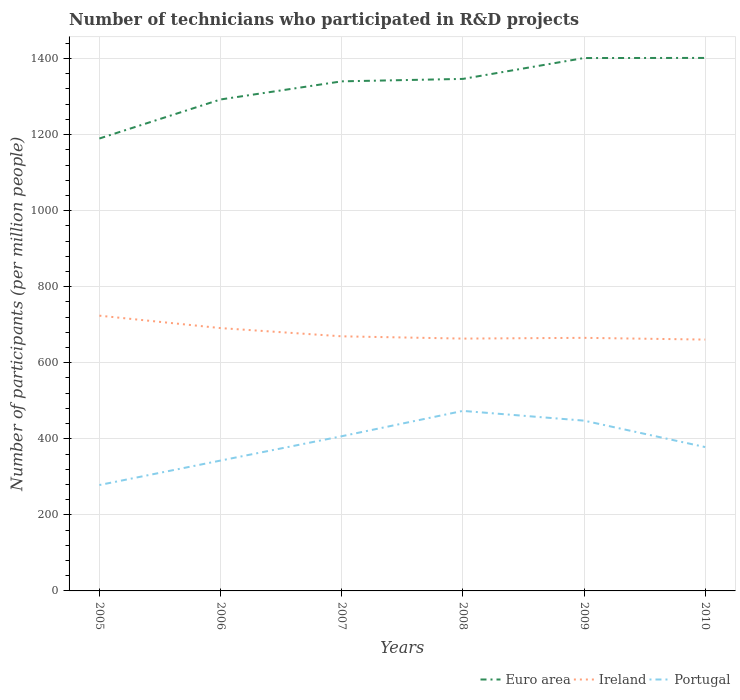How many different coloured lines are there?
Offer a very short reply. 3. Does the line corresponding to Euro area intersect with the line corresponding to Ireland?
Give a very brief answer. No. Is the number of lines equal to the number of legend labels?
Make the answer very short. Yes. Across all years, what is the maximum number of technicians who participated in R&D projects in Ireland?
Give a very brief answer. 660.99. In which year was the number of technicians who participated in R&D projects in Portugal maximum?
Your answer should be compact. 2005. What is the total number of technicians who participated in R&D projects in Ireland in the graph?
Keep it short and to the point. 4.57. What is the difference between the highest and the second highest number of technicians who participated in R&D projects in Ireland?
Provide a short and direct response. 62.9. Is the number of technicians who participated in R&D projects in Ireland strictly greater than the number of technicians who participated in R&D projects in Portugal over the years?
Offer a very short reply. No. What is the difference between two consecutive major ticks on the Y-axis?
Your answer should be very brief. 200. What is the title of the graph?
Provide a short and direct response. Number of technicians who participated in R&D projects. What is the label or title of the Y-axis?
Your response must be concise. Number of participants (per million people). What is the Number of participants (per million people) in Euro area in 2005?
Ensure brevity in your answer.  1189.74. What is the Number of participants (per million people) of Ireland in 2005?
Your answer should be compact. 723.89. What is the Number of participants (per million people) of Portugal in 2005?
Provide a short and direct response. 278.47. What is the Number of participants (per million people) in Euro area in 2006?
Offer a very short reply. 1292.42. What is the Number of participants (per million people) of Ireland in 2006?
Your answer should be compact. 691.21. What is the Number of participants (per million people) of Portugal in 2006?
Your answer should be very brief. 342.81. What is the Number of participants (per million people) of Euro area in 2007?
Offer a terse response. 1340.09. What is the Number of participants (per million people) in Ireland in 2007?
Give a very brief answer. 669.57. What is the Number of participants (per million people) in Portugal in 2007?
Keep it short and to the point. 406.8. What is the Number of participants (per million people) of Euro area in 2008?
Offer a very short reply. 1346.52. What is the Number of participants (per million people) in Ireland in 2008?
Your response must be concise. 663.59. What is the Number of participants (per million people) in Portugal in 2008?
Your response must be concise. 473.42. What is the Number of participants (per million people) in Euro area in 2009?
Provide a succinct answer. 1401.39. What is the Number of participants (per million people) in Ireland in 2009?
Offer a terse response. 665.55. What is the Number of participants (per million people) of Portugal in 2009?
Your answer should be compact. 447.8. What is the Number of participants (per million people) of Euro area in 2010?
Your response must be concise. 1401.67. What is the Number of participants (per million people) of Ireland in 2010?
Ensure brevity in your answer.  660.99. What is the Number of participants (per million people) of Portugal in 2010?
Offer a very short reply. 378.29. Across all years, what is the maximum Number of participants (per million people) in Euro area?
Offer a very short reply. 1401.67. Across all years, what is the maximum Number of participants (per million people) in Ireland?
Your response must be concise. 723.89. Across all years, what is the maximum Number of participants (per million people) in Portugal?
Your answer should be compact. 473.42. Across all years, what is the minimum Number of participants (per million people) of Euro area?
Offer a very short reply. 1189.74. Across all years, what is the minimum Number of participants (per million people) in Ireland?
Ensure brevity in your answer.  660.99. Across all years, what is the minimum Number of participants (per million people) of Portugal?
Offer a very short reply. 278.47. What is the total Number of participants (per million people) of Euro area in the graph?
Offer a very short reply. 7971.83. What is the total Number of participants (per million people) of Ireland in the graph?
Your answer should be very brief. 4074.8. What is the total Number of participants (per million people) in Portugal in the graph?
Your answer should be very brief. 2327.59. What is the difference between the Number of participants (per million people) of Euro area in 2005 and that in 2006?
Your response must be concise. -102.68. What is the difference between the Number of participants (per million people) in Ireland in 2005 and that in 2006?
Provide a succinct answer. 32.68. What is the difference between the Number of participants (per million people) of Portugal in 2005 and that in 2006?
Your answer should be compact. -64.34. What is the difference between the Number of participants (per million people) of Euro area in 2005 and that in 2007?
Give a very brief answer. -150.35. What is the difference between the Number of participants (per million people) of Ireland in 2005 and that in 2007?
Make the answer very short. 54.31. What is the difference between the Number of participants (per million people) in Portugal in 2005 and that in 2007?
Make the answer very short. -128.33. What is the difference between the Number of participants (per million people) in Euro area in 2005 and that in 2008?
Provide a succinct answer. -156.78. What is the difference between the Number of participants (per million people) of Ireland in 2005 and that in 2008?
Your answer should be very brief. 60.29. What is the difference between the Number of participants (per million people) in Portugal in 2005 and that in 2008?
Provide a succinct answer. -194.95. What is the difference between the Number of participants (per million people) of Euro area in 2005 and that in 2009?
Your response must be concise. -211.65. What is the difference between the Number of participants (per million people) in Ireland in 2005 and that in 2009?
Provide a succinct answer. 58.33. What is the difference between the Number of participants (per million people) in Portugal in 2005 and that in 2009?
Provide a short and direct response. -169.33. What is the difference between the Number of participants (per million people) of Euro area in 2005 and that in 2010?
Provide a short and direct response. -211.93. What is the difference between the Number of participants (per million people) of Ireland in 2005 and that in 2010?
Make the answer very short. 62.9. What is the difference between the Number of participants (per million people) in Portugal in 2005 and that in 2010?
Provide a succinct answer. -99.82. What is the difference between the Number of participants (per million people) of Euro area in 2006 and that in 2007?
Offer a terse response. -47.67. What is the difference between the Number of participants (per million people) in Ireland in 2006 and that in 2007?
Your answer should be very brief. 21.63. What is the difference between the Number of participants (per million people) in Portugal in 2006 and that in 2007?
Keep it short and to the point. -63.99. What is the difference between the Number of participants (per million people) of Euro area in 2006 and that in 2008?
Your answer should be very brief. -54.1. What is the difference between the Number of participants (per million people) of Ireland in 2006 and that in 2008?
Offer a very short reply. 27.61. What is the difference between the Number of participants (per million people) in Portugal in 2006 and that in 2008?
Provide a succinct answer. -130.61. What is the difference between the Number of participants (per million people) in Euro area in 2006 and that in 2009?
Give a very brief answer. -108.97. What is the difference between the Number of participants (per million people) of Ireland in 2006 and that in 2009?
Keep it short and to the point. 25.65. What is the difference between the Number of participants (per million people) of Portugal in 2006 and that in 2009?
Offer a very short reply. -104.99. What is the difference between the Number of participants (per million people) of Euro area in 2006 and that in 2010?
Offer a very short reply. -109.25. What is the difference between the Number of participants (per million people) of Ireland in 2006 and that in 2010?
Provide a succinct answer. 30.22. What is the difference between the Number of participants (per million people) in Portugal in 2006 and that in 2010?
Your answer should be very brief. -35.48. What is the difference between the Number of participants (per million people) of Euro area in 2007 and that in 2008?
Your answer should be very brief. -6.43. What is the difference between the Number of participants (per million people) in Ireland in 2007 and that in 2008?
Keep it short and to the point. 5.98. What is the difference between the Number of participants (per million people) in Portugal in 2007 and that in 2008?
Offer a terse response. -66.62. What is the difference between the Number of participants (per million people) of Euro area in 2007 and that in 2009?
Provide a succinct answer. -61.3. What is the difference between the Number of participants (per million people) of Ireland in 2007 and that in 2009?
Your answer should be very brief. 4.02. What is the difference between the Number of participants (per million people) in Portugal in 2007 and that in 2009?
Your answer should be very brief. -41. What is the difference between the Number of participants (per million people) of Euro area in 2007 and that in 2010?
Keep it short and to the point. -61.58. What is the difference between the Number of participants (per million people) in Ireland in 2007 and that in 2010?
Your answer should be compact. 8.59. What is the difference between the Number of participants (per million people) of Portugal in 2007 and that in 2010?
Ensure brevity in your answer.  28.51. What is the difference between the Number of participants (per million people) of Euro area in 2008 and that in 2009?
Give a very brief answer. -54.87. What is the difference between the Number of participants (per million people) in Ireland in 2008 and that in 2009?
Offer a terse response. -1.96. What is the difference between the Number of participants (per million people) of Portugal in 2008 and that in 2009?
Ensure brevity in your answer.  25.62. What is the difference between the Number of participants (per million people) of Euro area in 2008 and that in 2010?
Provide a succinct answer. -55.15. What is the difference between the Number of participants (per million people) of Ireland in 2008 and that in 2010?
Ensure brevity in your answer.  2.61. What is the difference between the Number of participants (per million people) of Portugal in 2008 and that in 2010?
Offer a terse response. 95.13. What is the difference between the Number of participants (per million people) of Euro area in 2009 and that in 2010?
Ensure brevity in your answer.  -0.28. What is the difference between the Number of participants (per million people) of Ireland in 2009 and that in 2010?
Your answer should be very brief. 4.57. What is the difference between the Number of participants (per million people) in Portugal in 2009 and that in 2010?
Offer a very short reply. 69.51. What is the difference between the Number of participants (per million people) in Euro area in 2005 and the Number of participants (per million people) in Ireland in 2006?
Give a very brief answer. 498.53. What is the difference between the Number of participants (per million people) in Euro area in 2005 and the Number of participants (per million people) in Portugal in 2006?
Provide a succinct answer. 846.93. What is the difference between the Number of participants (per million people) in Ireland in 2005 and the Number of participants (per million people) in Portugal in 2006?
Provide a short and direct response. 381.07. What is the difference between the Number of participants (per million people) in Euro area in 2005 and the Number of participants (per million people) in Ireland in 2007?
Your answer should be compact. 520.16. What is the difference between the Number of participants (per million people) of Euro area in 2005 and the Number of participants (per million people) of Portugal in 2007?
Your answer should be very brief. 782.94. What is the difference between the Number of participants (per million people) in Ireland in 2005 and the Number of participants (per million people) in Portugal in 2007?
Make the answer very short. 317.08. What is the difference between the Number of participants (per million people) of Euro area in 2005 and the Number of participants (per million people) of Ireland in 2008?
Your answer should be compact. 526.14. What is the difference between the Number of participants (per million people) of Euro area in 2005 and the Number of participants (per million people) of Portugal in 2008?
Offer a very short reply. 716.32. What is the difference between the Number of participants (per million people) in Ireland in 2005 and the Number of participants (per million people) in Portugal in 2008?
Keep it short and to the point. 250.47. What is the difference between the Number of participants (per million people) in Euro area in 2005 and the Number of participants (per million people) in Ireland in 2009?
Provide a short and direct response. 524.18. What is the difference between the Number of participants (per million people) of Euro area in 2005 and the Number of participants (per million people) of Portugal in 2009?
Make the answer very short. 741.94. What is the difference between the Number of participants (per million people) of Ireland in 2005 and the Number of participants (per million people) of Portugal in 2009?
Provide a succinct answer. 276.09. What is the difference between the Number of participants (per million people) in Euro area in 2005 and the Number of participants (per million people) in Ireland in 2010?
Offer a terse response. 528.75. What is the difference between the Number of participants (per million people) in Euro area in 2005 and the Number of participants (per million people) in Portugal in 2010?
Give a very brief answer. 811.45. What is the difference between the Number of participants (per million people) in Ireland in 2005 and the Number of participants (per million people) in Portugal in 2010?
Ensure brevity in your answer.  345.6. What is the difference between the Number of participants (per million people) in Euro area in 2006 and the Number of participants (per million people) in Ireland in 2007?
Your answer should be very brief. 622.85. What is the difference between the Number of participants (per million people) of Euro area in 2006 and the Number of participants (per million people) of Portugal in 2007?
Make the answer very short. 885.62. What is the difference between the Number of participants (per million people) of Ireland in 2006 and the Number of participants (per million people) of Portugal in 2007?
Offer a very short reply. 284.4. What is the difference between the Number of participants (per million people) in Euro area in 2006 and the Number of participants (per million people) in Ireland in 2008?
Offer a very short reply. 628.83. What is the difference between the Number of participants (per million people) in Euro area in 2006 and the Number of participants (per million people) in Portugal in 2008?
Your answer should be compact. 819. What is the difference between the Number of participants (per million people) in Ireland in 2006 and the Number of participants (per million people) in Portugal in 2008?
Provide a succinct answer. 217.79. What is the difference between the Number of participants (per million people) of Euro area in 2006 and the Number of participants (per million people) of Ireland in 2009?
Offer a terse response. 626.87. What is the difference between the Number of participants (per million people) of Euro area in 2006 and the Number of participants (per million people) of Portugal in 2009?
Provide a succinct answer. 844.62. What is the difference between the Number of participants (per million people) of Ireland in 2006 and the Number of participants (per million people) of Portugal in 2009?
Make the answer very short. 243.41. What is the difference between the Number of participants (per million people) in Euro area in 2006 and the Number of participants (per million people) in Ireland in 2010?
Your answer should be very brief. 631.43. What is the difference between the Number of participants (per million people) in Euro area in 2006 and the Number of participants (per million people) in Portugal in 2010?
Give a very brief answer. 914.13. What is the difference between the Number of participants (per million people) of Ireland in 2006 and the Number of participants (per million people) of Portugal in 2010?
Ensure brevity in your answer.  312.92. What is the difference between the Number of participants (per million people) of Euro area in 2007 and the Number of participants (per million people) of Ireland in 2008?
Offer a very short reply. 676.5. What is the difference between the Number of participants (per million people) in Euro area in 2007 and the Number of participants (per million people) in Portugal in 2008?
Keep it short and to the point. 866.67. What is the difference between the Number of participants (per million people) in Ireland in 2007 and the Number of participants (per million people) in Portugal in 2008?
Give a very brief answer. 196.16. What is the difference between the Number of participants (per million people) of Euro area in 2007 and the Number of participants (per million people) of Ireland in 2009?
Ensure brevity in your answer.  674.54. What is the difference between the Number of participants (per million people) of Euro area in 2007 and the Number of participants (per million people) of Portugal in 2009?
Provide a succinct answer. 892.29. What is the difference between the Number of participants (per million people) in Ireland in 2007 and the Number of participants (per million people) in Portugal in 2009?
Your response must be concise. 221.77. What is the difference between the Number of participants (per million people) in Euro area in 2007 and the Number of participants (per million people) in Ireland in 2010?
Ensure brevity in your answer.  679.1. What is the difference between the Number of participants (per million people) in Euro area in 2007 and the Number of participants (per million people) in Portugal in 2010?
Make the answer very short. 961.8. What is the difference between the Number of participants (per million people) of Ireland in 2007 and the Number of participants (per million people) of Portugal in 2010?
Provide a short and direct response. 291.28. What is the difference between the Number of participants (per million people) in Euro area in 2008 and the Number of participants (per million people) in Ireland in 2009?
Your answer should be compact. 680.97. What is the difference between the Number of participants (per million people) in Euro area in 2008 and the Number of participants (per million people) in Portugal in 2009?
Your response must be concise. 898.72. What is the difference between the Number of participants (per million people) of Ireland in 2008 and the Number of participants (per million people) of Portugal in 2009?
Provide a short and direct response. 215.8. What is the difference between the Number of participants (per million people) in Euro area in 2008 and the Number of participants (per million people) in Ireland in 2010?
Offer a very short reply. 685.53. What is the difference between the Number of participants (per million people) in Euro area in 2008 and the Number of participants (per million people) in Portugal in 2010?
Offer a terse response. 968.23. What is the difference between the Number of participants (per million people) of Ireland in 2008 and the Number of participants (per million people) of Portugal in 2010?
Ensure brevity in your answer.  285.3. What is the difference between the Number of participants (per million people) of Euro area in 2009 and the Number of participants (per million people) of Ireland in 2010?
Ensure brevity in your answer.  740.4. What is the difference between the Number of participants (per million people) of Euro area in 2009 and the Number of participants (per million people) of Portugal in 2010?
Your answer should be very brief. 1023.1. What is the difference between the Number of participants (per million people) of Ireland in 2009 and the Number of participants (per million people) of Portugal in 2010?
Your answer should be very brief. 287.26. What is the average Number of participants (per million people) in Euro area per year?
Keep it short and to the point. 1328.64. What is the average Number of participants (per million people) in Ireland per year?
Offer a very short reply. 679.13. What is the average Number of participants (per million people) of Portugal per year?
Your answer should be very brief. 387.93. In the year 2005, what is the difference between the Number of participants (per million people) in Euro area and Number of participants (per million people) in Ireland?
Keep it short and to the point. 465.85. In the year 2005, what is the difference between the Number of participants (per million people) in Euro area and Number of participants (per million people) in Portugal?
Offer a terse response. 911.27. In the year 2005, what is the difference between the Number of participants (per million people) in Ireland and Number of participants (per million people) in Portugal?
Offer a terse response. 445.42. In the year 2006, what is the difference between the Number of participants (per million people) of Euro area and Number of participants (per million people) of Ireland?
Offer a terse response. 601.22. In the year 2006, what is the difference between the Number of participants (per million people) in Euro area and Number of participants (per million people) in Portugal?
Your response must be concise. 949.61. In the year 2006, what is the difference between the Number of participants (per million people) of Ireland and Number of participants (per million people) of Portugal?
Make the answer very short. 348.39. In the year 2007, what is the difference between the Number of participants (per million people) of Euro area and Number of participants (per million people) of Ireland?
Your response must be concise. 670.52. In the year 2007, what is the difference between the Number of participants (per million people) in Euro area and Number of participants (per million people) in Portugal?
Your answer should be compact. 933.29. In the year 2007, what is the difference between the Number of participants (per million people) in Ireland and Number of participants (per million people) in Portugal?
Keep it short and to the point. 262.77. In the year 2008, what is the difference between the Number of participants (per million people) of Euro area and Number of participants (per million people) of Ireland?
Your response must be concise. 682.93. In the year 2008, what is the difference between the Number of participants (per million people) of Euro area and Number of participants (per million people) of Portugal?
Your answer should be very brief. 873.1. In the year 2008, what is the difference between the Number of participants (per million people) of Ireland and Number of participants (per million people) of Portugal?
Your answer should be compact. 190.18. In the year 2009, what is the difference between the Number of participants (per million people) of Euro area and Number of participants (per million people) of Ireland?
Your answer should be very brief. 735.84. In the year 2009, what is the difference between the Number of participants (per million people) in Euro area and Number of participants (per million people) in Portugal?
Offer a terse response. 953.59. In the year 2009, what is the difference between the Number of participants (per million people) of Ireland and Number of participants (per million people) of Portugal?
Give a very brief answer. 217.76. In the year 2010, what is the difference between the Number of participants (per million people) of Euro area and Number of participants (per million people) of Ireland?
Your answer should be compact. 740.68. In the year 2010, what is the difference between the Number of participants (per million people) in Euro area and Number of participants (per million people) in Portugal?
Provide a short and direct response. 1023.38. In the year 2010, what is the difference between the Number of participants (per million people) in Ireland and Number of participants (per million people) in Portugal?
Your answer should be compact. 282.7. What is the ratio of the Number of participants (per million people) in Euro area in 2005 to that in 2006?
Ensure brevity in your answer.  0.92. What is the ratio of the Number of participants (per million people) of Ireland in 2005 to that in 2006?
Provide a succinct answer. 1.05. What is the ratio of the Number of participants (per million people) of Portugal in 2005 to that in 2006?
Ensure brevity in your answer.  0.81. What is the ratio of the Number of participants (per million people) in Euro area in 2005 to that in 2007?
Your response must be concise. 0.89. What is the ratio of the Number of participants (per million people) in Ireland in 2005 to that in 2007?
Your answer should be compact. 1.08. What is the ratio of the Number of participants (per million people) of Portugal in 2005 to that in 2007?
Ensure brevity in your answer.  0.68. What is the ratio of the Number of participants (per million people) of Euro area in 2005 to that in 2008?
Make the answer very short. 0.88. What is the ratio of the Number of participants (per million people) of Ireland in 2005 to that in 2008?
Provide a short and direct response. 1.09. What is the ratio of the Number of participants (per million people) of Portugal in 2005 to that in 2008?
Keep it short and to the point. 0.59. What is the ratio of the Number of participants (per million people) of Euro area in 2005 to that in 2009?
Provide a short and direct response. 0.85. What is the ratio of the Number of participants (per million people) of Ireland in 2005 to that in 2009?
Offer a very short reply. 1.09. What is the ratio of the Number of participants (per million people) of Portugal in 2005 to that in 2009?
Offer a very short reply. 0.62. What is the ratio of the Number of participants (per million people) in Euro area in 2005 to that in 2010?
Give a very brief answer. 0.85. What is the ratio of the Number of participants (per million people) of Ireland in 2005 to that in 2010?
Offer a very short reply. 1.1. What is the ratio of the Number of participants (per million people) of Portugal in 2005 to that in 2010?
Ensure brevity in your answer.  0.74. What is the ratio of the Number of participants (per million people) in Euro area in 2006 to that in 2007?
Offer a terse response. 0.96. What is the ratio of the Number of participants (per million people) in Ireland in 2006 to that in 2007?
Provide a short and direct response. 1.03. What is the ratio of the Number of participants (per million people) in Portugal in 2006 to that in 2007?
Give a very brief answer. 0.84. What is the ratio of the Number of participants (per million people) of Euro area in 2006 to that in 2008?
Ensure brevity in your answer.  0.96. What is the ratio of the Number of participants (per million people) of Ireland in 2006 to that in 2008?
Your answer should be compact. 1.04. What is the ratio of the Number of participants (per million people) of Portugal in 2006 to that in 2008?
Provide a short and direct response. 0.72. What is the ratio of the Number of participants (per million people) in Euro area in 2006 to that in 2009?
Your response must be concise. 0.92. What is the ratio of the Number of participants (per million people) in Ireland in 2006 to that in 2009?
Ensure brevity in your answer.  1.04. What is the ratio of the Number of participants (per million people) of Portugal in 2006 to that in 2009?
Your answer should be very brief. 0.77. What is the ratio of the Number of participants (per million people) of Euro area in 2006 to that in 2010?
Offer a very short reply. 0.92. What is the ratio of the Number of participants (per million people) in Ireland in 2006 to that in 2010?
Keep it short and to the point. 1.05. What is the ratio of the Number of participants (per million people) in Portugal in 2006 to that in 2010?
Your answer should be very brief. 0.91. What is the ratio of the Number of participants (per million people) of Ireland in 2007 to that in 2008?
Offer a very short reply. 1.01. What is the ratio of the Number of participants (per million people) of Portugal in 2007 to that in 2008?
Offer a very short reply. 0.86. What is the ratio of the Number of participants (per million people) in Euro area in 2007 to that in 2009?
Ensure brevity in your answer.  0.96. What is the ratio of the Number of participants (per million people) in Portugal in 2007 to that in 2009?
Provide a short and direct response. 0.91. What is the ratio of the Number of participants (per million people) of Euro area in 2007 to that in 2010?
Your answer should be very brief. 0.96. What is the ratio of the Number of participants (per million people) of Portugal in 2007 to that in 2010?
Offer a very short reply. 1.08. What is the ratio of the Number of participants (per million people) in Euro area in 2008 to that in 2009?
Your answer should be very brief. 0.96. What is the ratio of the Number of participants (per million people) in Ireland in 2008 to that in 2009?
Provide a succinct answer. 1. What is the ratio of the Number of participants (per million people) in Portugal in 2008 to that in 2009?
Keep it short and to the point. 1.06. What is the ratio of the Number of participants (per million people) in Euro area in 2008 to that in 2010?
Offer a terse response. 0.96. What is the ratio of the Number of participants (per million people) of Ireland in 2008 to that in 2010?
Give a very brief answer. 1. What is the ratio of the Number of participants (per million people) of Portugal in 2008 to that in 2010?
Your response must be concise. 1.25. What is the ratio of the Number of participants (per million people) of Ireland in 2009 to that in 2010?
Your answer should be very brief. 1.01. What is the ratio of the Number of participants (per million people) of Portugal in 2009 to that in 2010?
Provide a short and direct response. 1.18. What is the difference between the highest and the second highest Number of participants (per million people) of Euro area?
Offer a terse response. 0.28. What is the difference between the highest and the second highest Number of participants (per million people) of Ireland?
Your answer should be compact. 32.68. What is the difference between the highest and the second highest Number of participants (per million people) in Portugal?
Offer a very short reply. 25.62. What is the difference between the highest and the lowest Number of participants (per million people) of Euro area?
Make the answer very short. 211.93. What is the difference between the highest and the lowest Number of participants (per million people) of Ireland?
Your answer should be very brief. 62.9. What is the difference between the highest and the lowest Number of participants (per million people) of Portugal?
Provide a short and direct response. 194.95. 